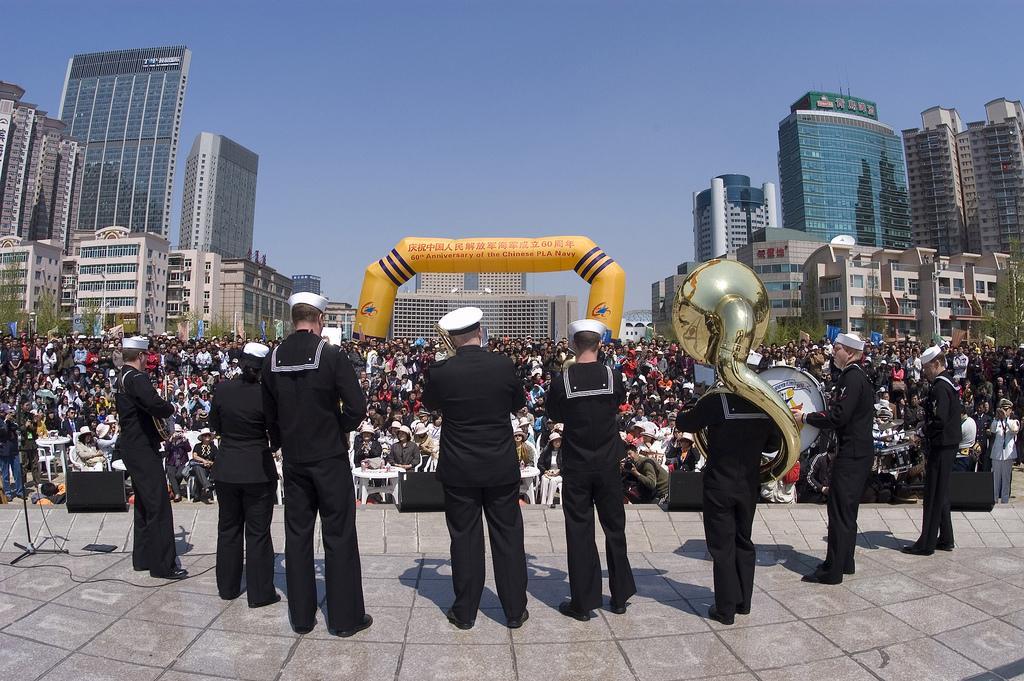In one or two sentences, can you explain what this image depicts? This picture describe about musician wearing black color coat and pant holding big golden saxophone in the hand and playing the ,music on the stage. In the background we can see many people sitting and watching the music show. 